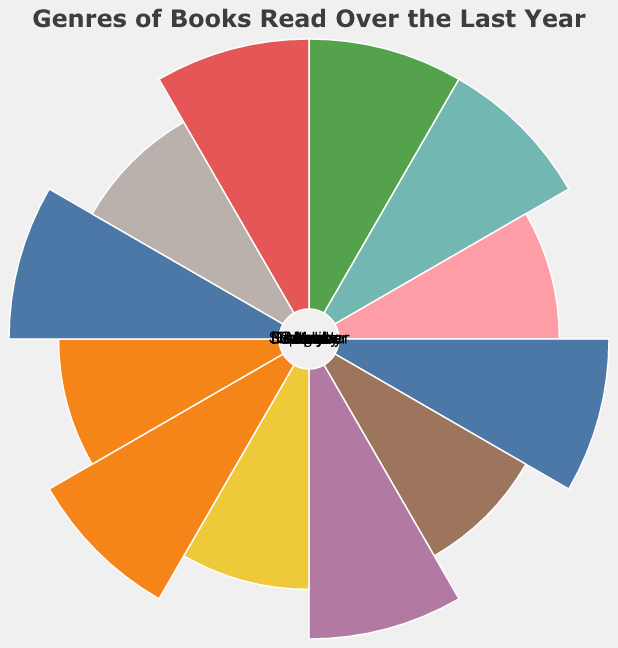How many genres are displayed in the figure? The figure shows the genres as labels and arcs in the Polar Chart. By counting these labels, you can determine how many genres are displayed.
Answer: 7 Which month has the most Fantasy books read? By observing the radius of arcs labeled "Fantasy" for each month, the month with the longest arc has the most Fantasy books read.
Answer: January How many Mystery books were read in December? Locate the arc related to "December" and check its length for the "Mystery" data point. The length corresponds to the number of books.
Answer: 2 Which months have the highest number of Science Fiction books read? Compare the radii of arcs labeled "Science Fiction" across the months. The longest arcs indicate the highest number of Science Fiction books read.
Answer: August What is the fewest number of Self-help books read in a single month, and which month(s) does this occur? Evaluate the arcs for "Self-help." The shortest arcs indicate the fewest number of Self-help books read.
Answer: March, July, November What is the average number of Horror books read per month? Calculate the total number of Horror books read over the year and divide by 12. By summing up the Horror book counts (1+1+2+3+1+1+2+1+2+2+1+1=20) then dividing by 12, you get the average.
Answer: 1.67 Compare the number of Non-fiction books read in the first half of the year to the second half. Which period has more? Sum the Non-fiction books read from January to June and compare it to the sum from July to December. First half: 2+2+3+2+1+2=12, Second half: 3+1+2+2+2+1=11.
Answer: First half Which genre has the most consistent reading pattern throughout the year? Check for the genre with similar arc lengths for each month. Look at the arcs for each genre and see which one has the least variation in size.
Answer: Sci-Fi In which month were the highest number of total books read? Sum the arcs of each genre for every month and find the month with the highest total sum. Observe the figure and add the arc lengths for each month.
Answer: January Which two months have the greatest difference in Literary Fiction books read? Compare the arc lengths for "Literary Fiction" among all months, and identify the two with the greatest difference. April and June have the greatest deviation in arc lengths.
Answer: April and June 